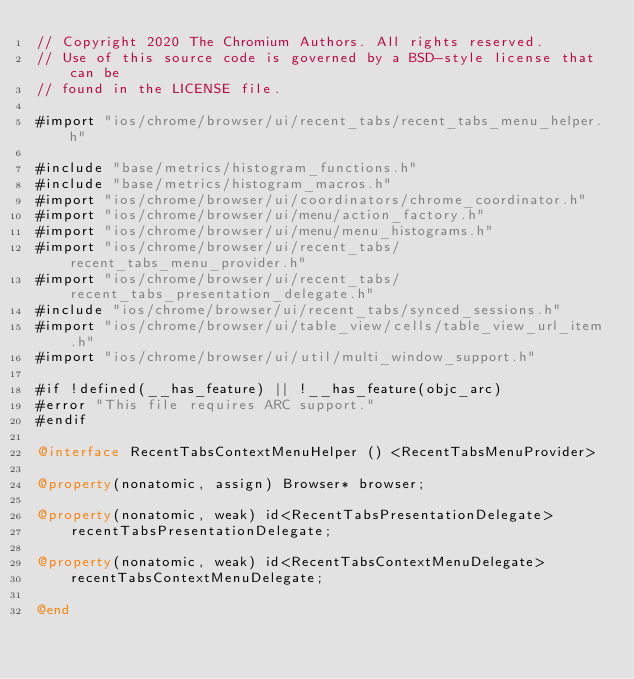Convert code to text. <code><loc_0><loc_0><loc_500><loc_500><_ObjectiveC_>// Copyright 2020 The Chromium Authors. All rights reserved.
// Use of this source code is governed by a BSD-style license that can be
// found in the LICENSE file.

#import "ios/chrome/browser/ui/recent_tabs/recent_tabs_menu_helper.h"

#include "base/metrics/histogram_functions.h"
#include "base/metrics/histogram_macros.h"
#import "ios/chrome/browser/ui/coordinators/chrome_coordinator.h"
#import "ios/chrome/browser/ui/menu/action_factory.h"
#import "ios/chrome/browser/ui/menu/menu_histograms.h"
#import "ios/chrome/browser/ui/recent_tabs/recent_tabs_menu_provider.h"
#import "ios/chrome/browser/ui/recent_tabs/recent_tabs_presentation_delegate.h"
#include "ios/chrome/browser/ui/recent_tabs/synced_sessions.h"
#import "ios/chrome/browser/ui/table_view/cells/table_view_url_item.h"
#import "ios/chrome/browser/ui/util/multi_window_support.h"

#if !defined(__has_feature) || !__has_feature(objc_arc)
#error "This file requires ARC support."
#endif

@interface RecentTabsContextMenuHelper () <RecentTabsMenuProvider>

@property(nonatomic, assign) Browser* browser;

@property(nonatomic, weak) id<RecentTabsPresentationDelegate>
    recentTabsPresentationDelegate;

@property(nonatomic, weak) id<RecentTabsContextMenuDelegate>
    recentTabsContextMenuDelegate;

@end
</code> 